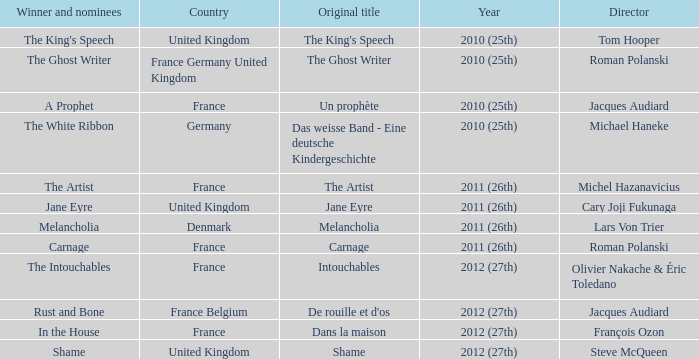Would you be able to parse every entry in this table? {'header': ['Winner and nominees', 'Country', 'Original title', 'Year', 'Director'], 'rows': [["The King's Speech", 'United Kingdom', "The King's Speech", '2010 (25th)', 'Tom Hooper'], ['The Ghost Writer', 'France Germany United Kingdom', 'The Ghost Writer', '2010 (25th)', 'Roman Polanski'], ['A Prophet', 'France', 'Un prophète', '2010 (25th)', 'Jacques Audiard'], ['The White Ribbon', 'Germany', 'Das weisse Band - Eine deutsche Kindergeschichte', '2010 (25th)', 'Michael Haneke'], ['The Artist', 'France', 'The Artist', '2011 (26th)', 'Michel Hazanavicius'], ['Jane Eyre', 'United Kingdom', 'Jane Eyre', '2011 (26th)', 'Cary Joji Fukunaga'], ['Melancholia', 'Denmark', 'Melancholia', '2011 (26th)', 'Lars Von Trier'], ['Carnage', 'France', 'Carnage', '2011 (26th)', 'Roman Polanski'], ['The Intouchables', 'France', 'Intouchables', '2012 (27th)', 'Olivier Nakache & Éric Toledano'], ['Rust and Bone', 'France Belgium', "De rouille et d'os", '2012 (27th)', 'Jacques Audiard'], ['In the House', 'France', 'Dans la maison', '2012 (27th)', 'François Ozon'], ['Shame', 'United Kingdom', 'Shame', '2012 (27th)', 'Steve McQueen']]} Who was the director of the king's speech? Tom Hooper. 